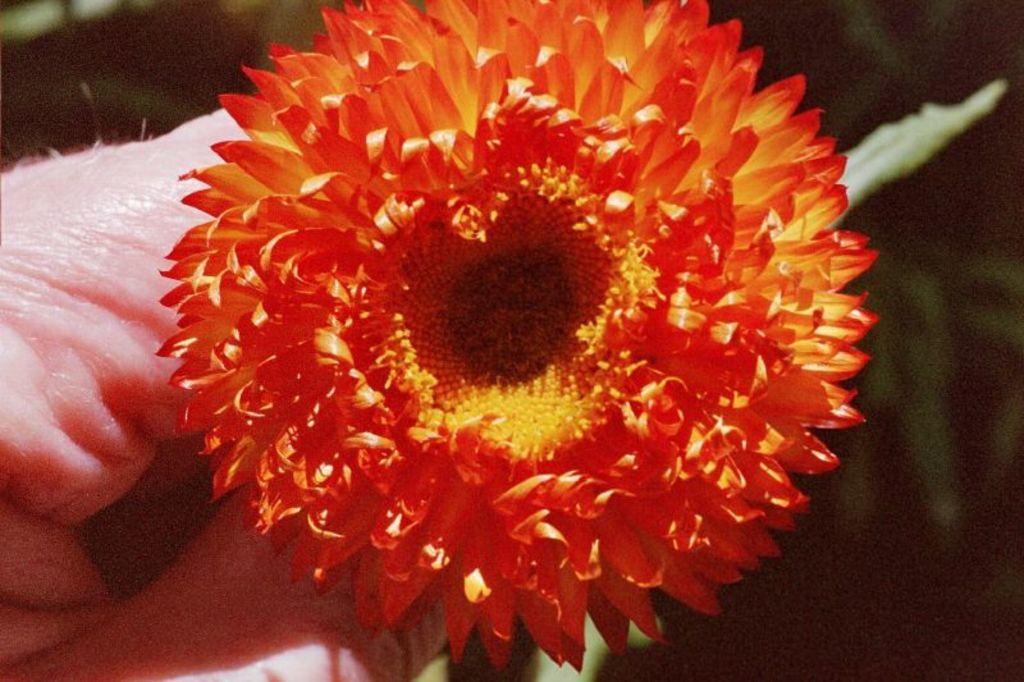Could you give a brief overview of what you see in this image? In this image there is a flower in the hand of the person in the front and the background is blurry. 